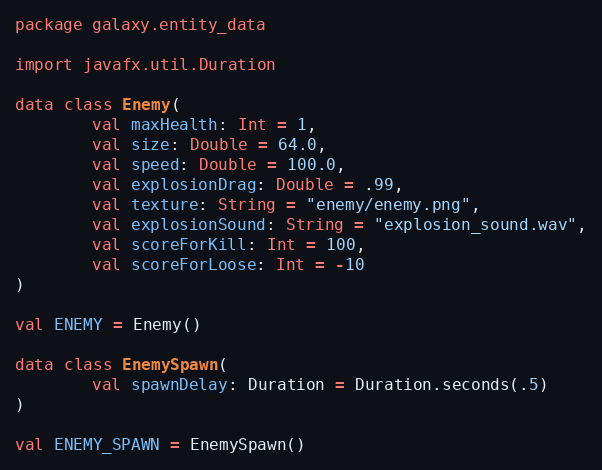Convert code to text. <code><loc_0><loc_0><loc_500><loc_500><_Kotlin_>package galaxy.entity_data

import javafx.util.Duration

data class Enemy(
        val maxHealth: Int = 1,
        val size: Double = 64.0,
        val speed: Double = 100.0,
        val explosionDrag: Double = .99,
        val texture: String = "enemy/enemy.png",
        val explosionSound: String = "explosion_sound.wav",
        val scoreForKill: Int = 100,
        val scoreForLoose: Int = -10
)

val ENEMY = Enemy()

data class EnemySpawn(
        val spawnDelay: Duration = Duration.seconds(.5)
)

val ENEMY_SPAWN = EnemySpawn()</code> 